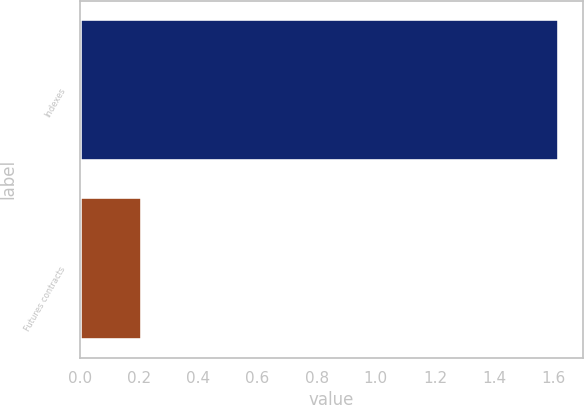Convert chart to OTSL. <chart><loc_0><loc_0><loc_500><loc_500><bar_chart><fcel>Indexes<fcel>Futures contracts<nl><fcel>1.62<fcel>0.21<nl></chart> 